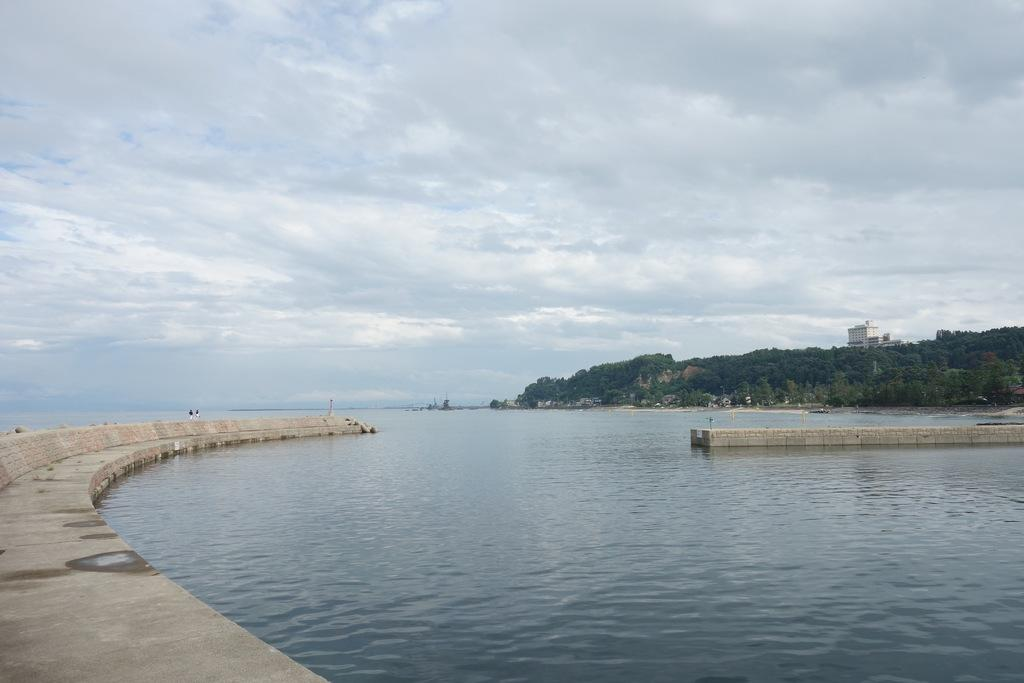What can be seen in the sky in the image? The sky with clouds is visible in the image. What type of natural feature is present near the water? There is a body of water (sea) in the image. What structure connects the land areas in the image? A walkway bridge is present in the image. What type of vegetation is visible in the image? Trees are visible in the image. What type of geographical feature can be seen in the background? Hills are present in the image. What type of man-made structure is visible in the image? There is a building in the image. How many bottles are floating in the sea in the image? There are no bottles visible in the image; it only features a body of water (sea). What type of change is happening to the building in the image? There is no indication of any change happening to the building in the image; it appears to be a static structure. 